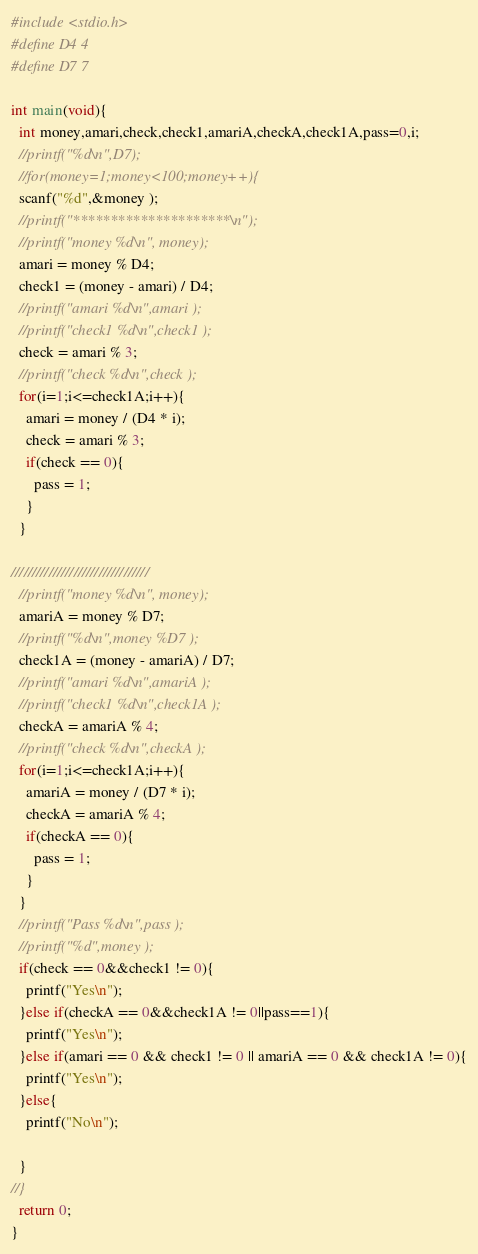<code> <loc_0><loc_0><loc_500><loc_500><_C_>#include <stdio.h>
#define D4 4
#define D7 7

int main(void){
  int money,amari,check,check1,amariA,checkA,check1A,pass=0,i;
  //printf("%d\n",D7);
  //for(money=1;money<100;money++){
  scanf("%d",&money );
  //printf("*********************\n");
  //printf("money %d\n", money);
  amari = money % D4;
  check1 = (money - amari) / D4;
  //printf("amari %d\n",amari );
  //printf("check1 %d\n",check1 );
  check = amari % 3;
  //printf("check %d\n",check );
  for(i=1;i<=check1A;i++){
    amari = money / (D4 * i);
    check = amari % 3;
    if(check == 0){
      pass = 1;
    }
  }

/////////////////////////////////
  //printf("money %d\n", money);
  amariA = money % D7;
  //printf("%d\n",money %D7 );
  check1A = (money - amariA) / D7;
  //printf("amari %d\n",amariA );
  //printf("check1 %d\n",check1A );
  checkA = amariA % 4;
  //printf("check %d\n",checkA );
  for(i=1;i<=check1A;i++){
    amariA = money / (D7 * i);
    checkA = amariA % 4;
    if(checkA == 0){
      pass = 1;
    }
  }
  //printf("Pass %d\n",pass );
  //printf("%d",money );
  if(check == 0&&check1 != 0){
    printf("Yes\n");
  }else if(checkA == 0&&check1A != 0||pass==1){
    printf("Yes\n");
  }else if(amari == 0 && check1 != 0 || amariA == 0 && check1A != 0){
    printf("Yes\n");
  }else{
    printf("No\n");

  }
//}
  return 0;
}
</code> 